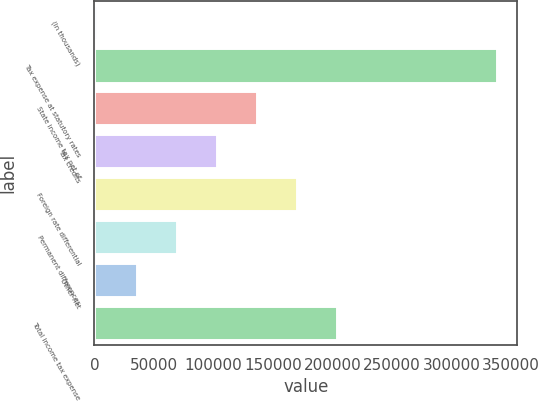Convert chart to OTSL. <chart><loc_0><loc_0><loc_500><loc_500><bar_chart><fcel>(In thousands)<fcel>Tax expense at statutory rates<fcel>State income tax net of<fcel>Tax credits<fcel>Foreign rate differential<fcel>Permanent differences<fcel>Other net<fcel>Total income tax expense<nl><fcel>2017<fcel>338495<fcel>136608<fcel>102960<fcel>170256<fcel>69312.6<fcel>35664.8<fcel>203904<nl></chart> 